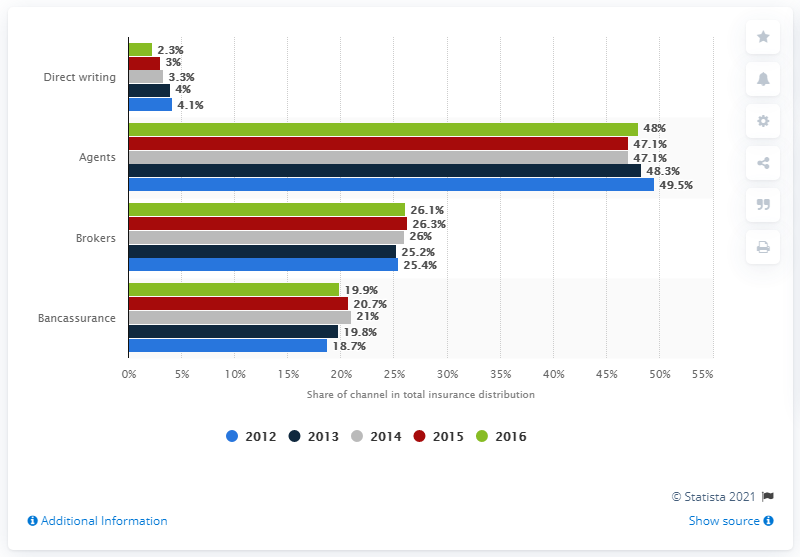Indicate a few pertinent items in this graphic. The market share of life insurance distribution channels in Germany was in 2012. 